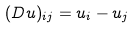Convert formula to latex. <formula><loc_0><loc_0><loc_500><loc_500>( D u ) _ { i j } = u _ { i } - u _ { j }</formula> 